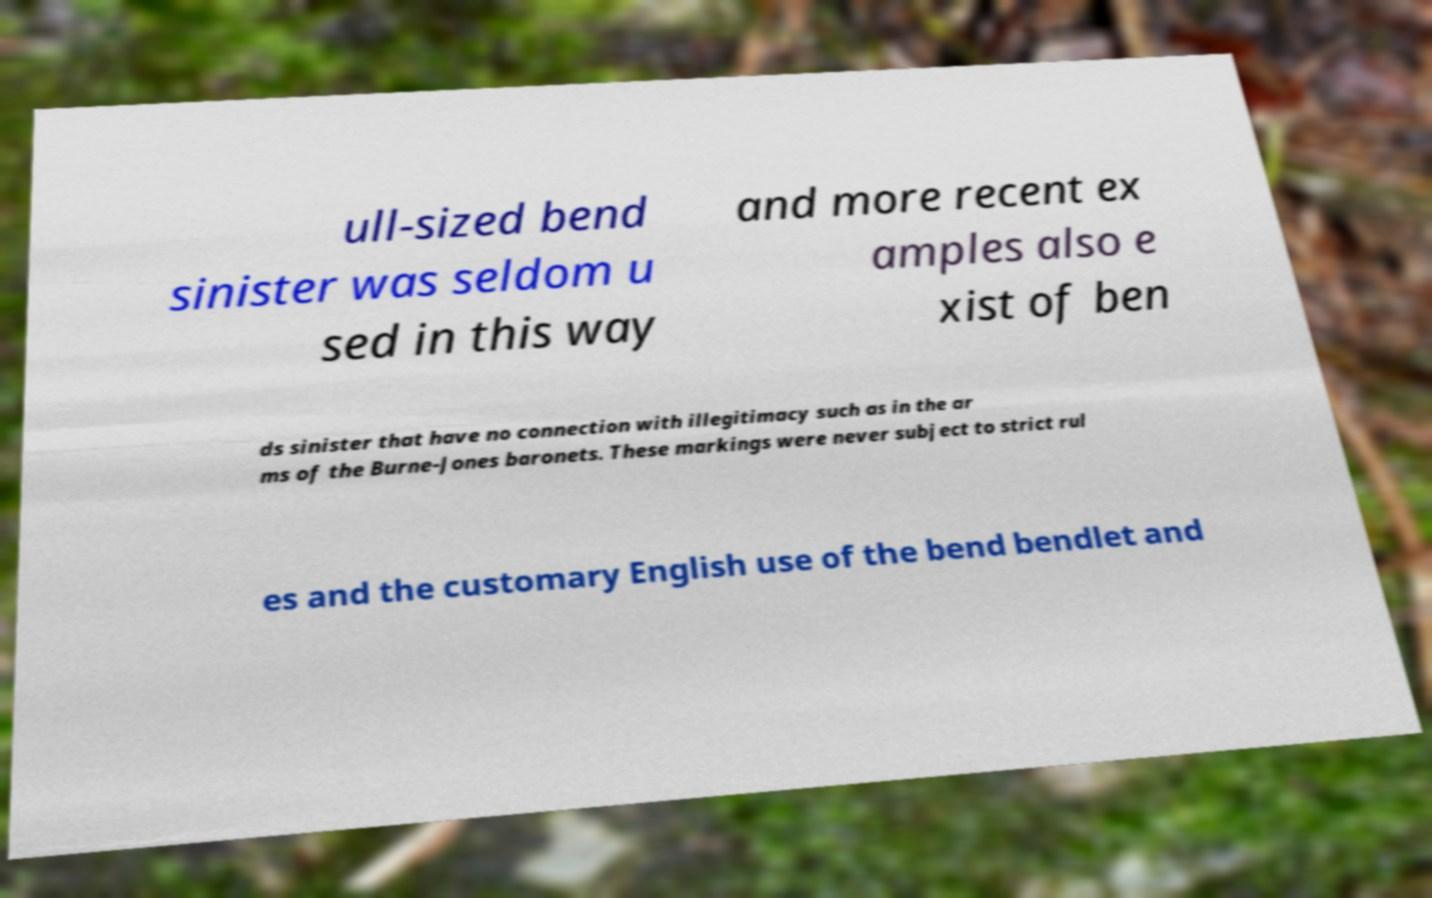For documentation purposes, I need the text within this image transcribed. Could you provide that? ull-sized bend sinister was seldom u sed in this way and more recent ex amples also e xist of ben ds sinister that have no connection with illegitimacy such as in the ar ms of the Burne-Jones baronets. These markings were never subject to strict rul es and the customary English use of the bend bendlet and 